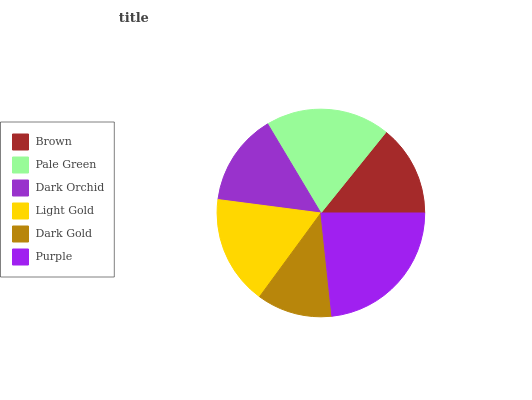Is Dark Gold the minimum?
Answer yes or no. Yes. Is Purple the maximum?
Answer yes or no. Yes. Is Pale Green the minimum?
Answer yes or no. No. Is Pale Green the maximum?
Answer yes or no. No. Is Pale Green greater than Brown?
Answer yes or no. Yes. Is Brown less than Pale Green?
Answer yes or no. Yes. Is Brown greater than Pale Green?
Answer yes or no. No. Is Pale Green less than Brown?
Answer yes or no. No. Is Light Gold the high median?
Answer yes or no. Yes. Is Dark Orchid the low median?
Answer yes or no. Yes. Is Pale Green the high median?
Answer yes or no. No. Is Dark Gold the low median?
Answer yes or no. No. 